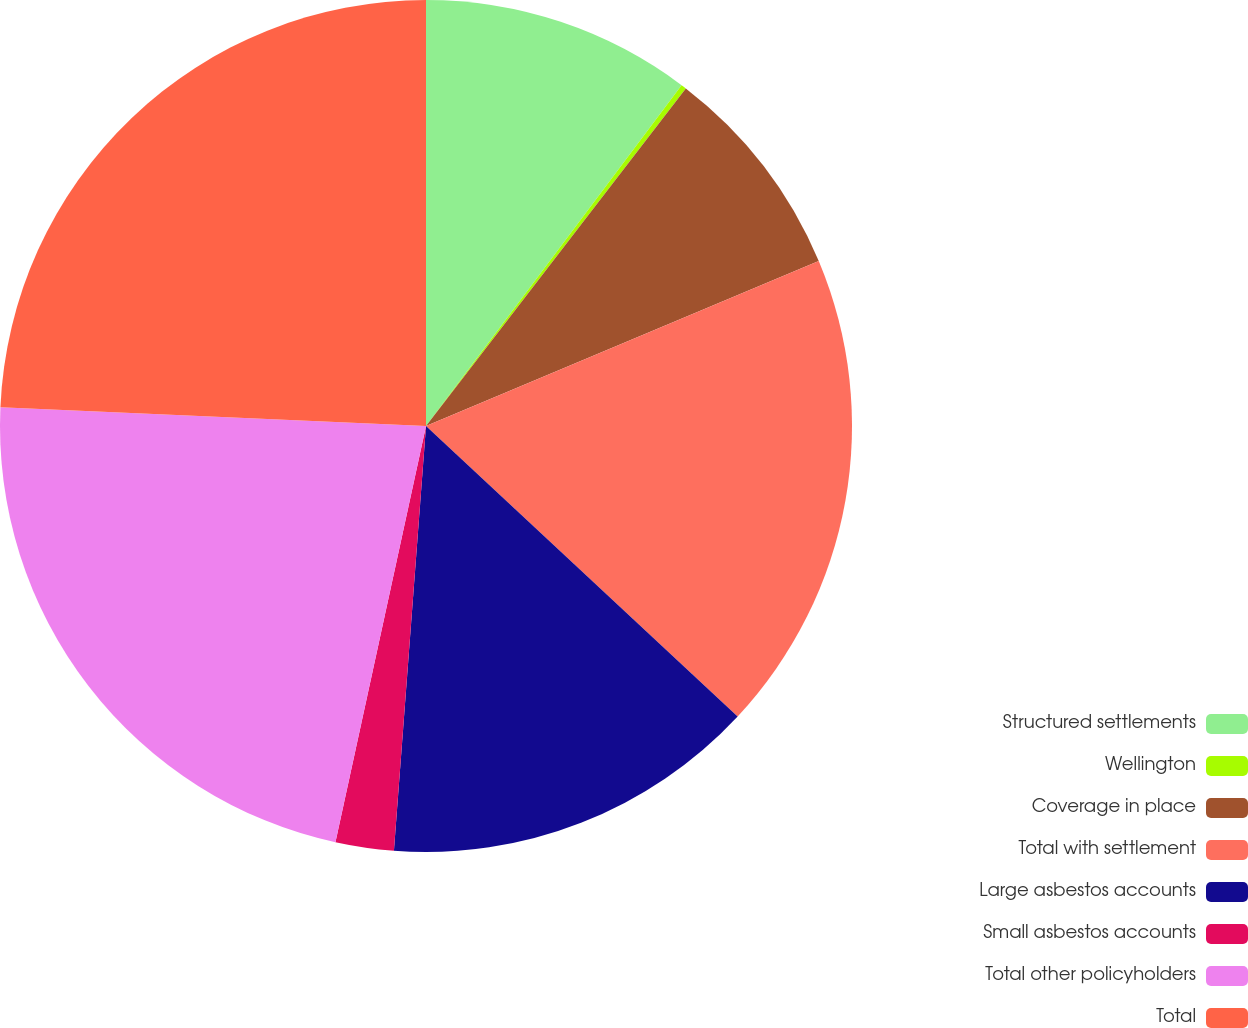Convert chart. <chart><loc_0><loc_0><loc_500><loc_500><pie_chart><fcel>Structured settlements<fcel>Wellington<fcel>Coverage in place<fcel>Total with settlement<fcel>Large asbestos accounts<fcel>Small asbestos accounts<fcel>Total other policyholders<fcel>Total<nl><fcel>10.24%<fcel>0.2%<fcel>8.23%<fcel>18.27%<fcel>14.26%<fcel>2.21%<fcel>22.29%<fcel>24.3%<nl></chart> 